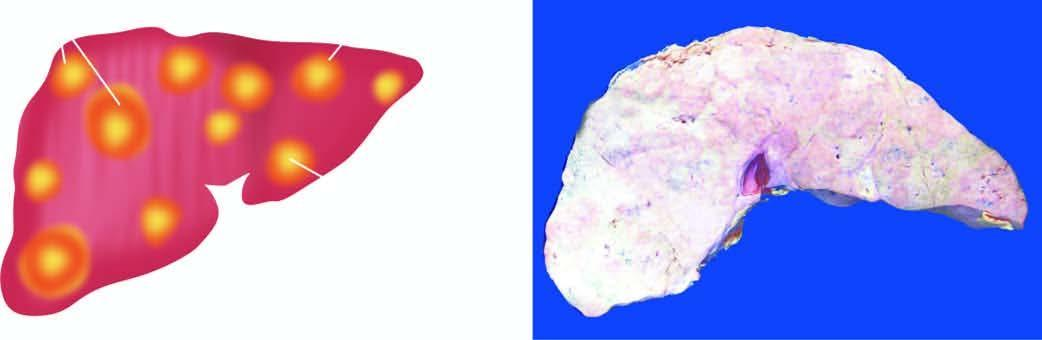where is metastatic tumour deposits in the liver seen?
Answer the question using a single word or phrase. On sectioned surface 